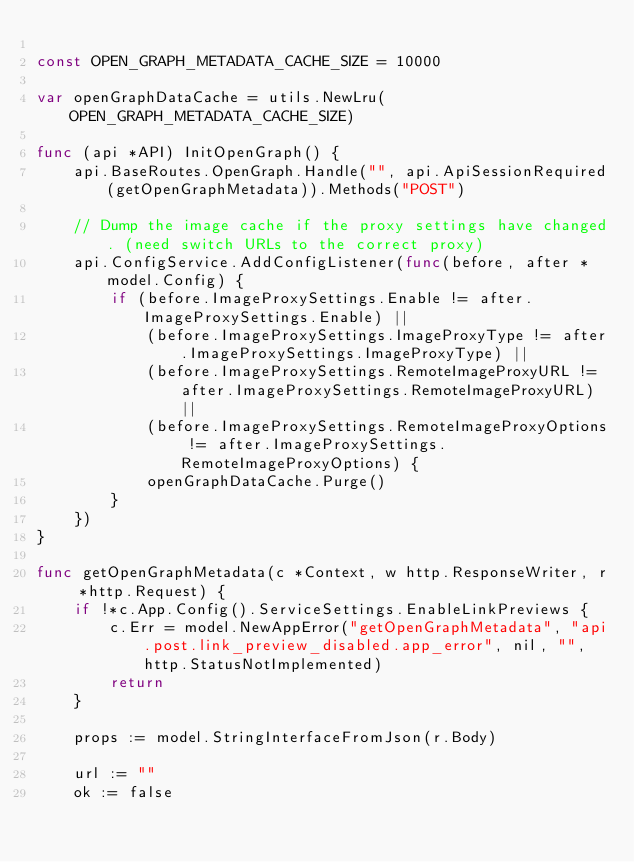Convert code to text. <code><loc_0><loc_0><loc_500><loc_500><_Go_>
const OPEN_GRAPH_METADATA_CACHE_SIZE = 10000

var openGraphDataCache = utils.NewLru(OPEN_GRAPH_METADATA_CACHE_SIZE)

func (api *API) InitOpenGraph() {
	api.BaseRoutes.OpenGraph.Handle("", api.ApiSessionRequired(getOpenGraphMetadata)).Methods("POST")

	// Dump the image cache if the proxy settings have changed. (need switch URLs to the correct proxy)
	api.ConfigService.AddConfigListener(func(before, after *model.Config) {
		if (before.ImageProxySettings.Enable != after.ImageProxySettings.Enable) ||
			(before.ImageProxySettings.ImageProxyType != after.ImageProxySettings.ImageProxyType) ||
			(before.ImageProxySettings.RemoteImageProxyURL != after.ImageProxySettings.RemoteImageProxyURL) ||
			(before.ImageProxySettings.RemoteImageProxyOptions != after.ImageProxySettings.RemoteImageProxyOptions) {
			openGraphDataCache.Purge()
		}
	})
}

func getOpenGraphMetadata(c *Context, w http.ResponseWriter, r *http.Request) {
	if !*c.App.Config().ServiceSettings.EnableLinkPreviews {
		c.Err = model.NewAppError("getOpenGraphMetadata", "api.post.link_preview_disabled.app_error", nil, "", http.StatusNotImplemented)
		return
	}

	props := model.StringInterfaceFromJson(r.Body)

	url := ""
	ok := false</code> 